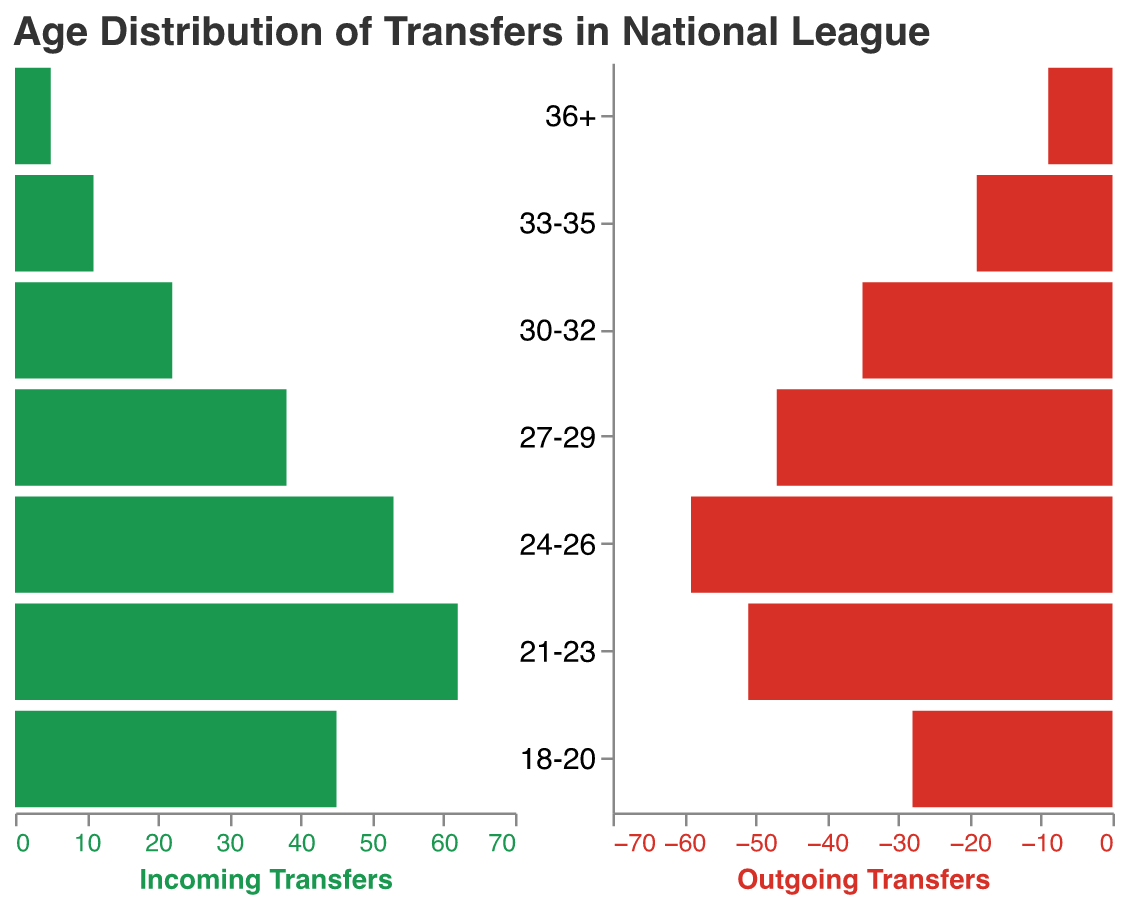What's the title of the figure? The title of the figure is displayed at the top of the plot in a larger font. The title reads "Age Distribution of Transfers in National League".
Answer: Age Distribution of Transfers in National League What's the age group with the highest number of incoming transfers? By examining the height of the bars in the incoming section, the age group "21-23" has the highest bar.
Answer: 21-23 What is the number of outgoing transfers for the age group 27-29? Look at the length of the bar corresponding to the age group "27-29" in the outgoing section. The label on the x-axis indicates 47 outgoing transfers.
Answer: 47 Which age group has more incoming transfers than outgoing transfers? Check each age group and compare the lengths of incoming and outgoing bars: "18-20", "21-23", and "30-32" all have higher incoming than outgoing bars.
Answer: 18-20, 21-23, 30-32 What is the difference in the number of transfers for the age group 24-26? For the age group "24-26", the incoming transfers are 53, and the outgoing transfers are 59. The difference (outgoing - incoming) is 59 - 53 = 6.
Answer: 6 Between which ages are the outgoing transfers consistently higher than incoming transfers? Compare the bars for each age group. From "24-26" through "36+", the outgoing bars are consistently higher than the incoming bars.
Answer: 24-26 to 36+ How many total incoming transfers are in the age groups 18-20 and 21-23 combined? Add the number of incoming transfers for "18-20" (45) and "21-23" (62) for a total of 45 + 62 = 107.
Answer: 107 What is the average number of incoming transfers for the age groups 33-35 and 36+? Add the number of incoming transfers for "33-35" (11) and "36+" (5) and divide by 2 for the average: (11 + 5) / 2 = 8.
Answer: 8 Is the number of outgoing transfers greater than the number of incoming transfers for the age group 30-32? Compare the outgoing (35) and incoming (22) transfers for the age group "30-32". Yes, 35 is greater than 22.
Answer: Yes 